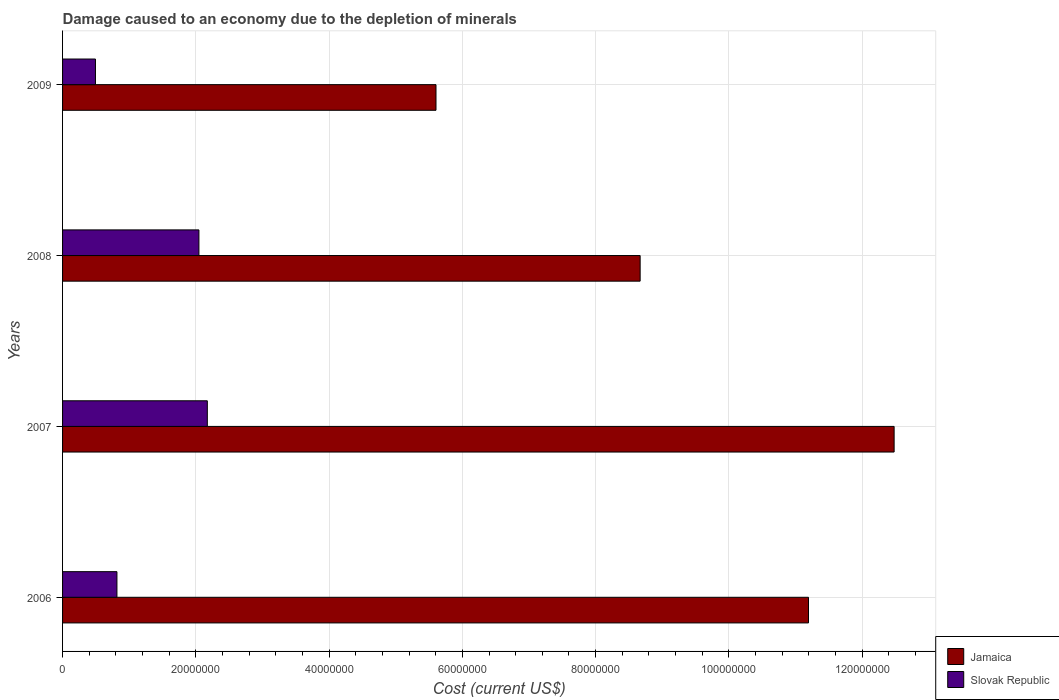How many different coloured bars are there?
Your response must be concise. 2. How many bars are there on the 2nd tick from the top?
Offer a very short reply. 2. What is the label of the 4th group of bars from the top?
Offer a very short reply. 2006. In how many cases, is the number of bars for a given year not equal to the number of legend labels?
Ensure brevity in your answer.  0. What is the cost of damage caused due to the depletion of minerals in Jamaica in 2007?
Give a very brief answer. 1.25e+08. Across all years, what is the maximum cost of damage caused due to the depletion of minerals in Slovak Republic?
Offer a very short reply. 2.17e+07. Across all years, what is the minimum cost of damage caused due to the depletion of minerals in Jamaica?
Ensure brevity in your answer.  5.60e+07. In which year was the cost of damage caused due to the depletion of minerals in Jamaica maximum?
Offer a very short reply. 2007. What is the total cost of damage caused due to the depletion of minerals in Jamaica in the graph?
Provide a short and direct response. 3.79e+08. What is the difference between the cost of damage caused due to the depletion of minerals in Slovak Republic in 2006 and that in 2007?
Your answer should be very brief. -1.36e+07. What is the difference between the cost of damage caused due to the depletion of minerals in Jamaica in 2008 and the cost of damage caused due to the depletion of minerals in Slovak Republic in 2007?
Keep it short and to the point. 6.50e+07. What is the average cost of damage caused due to the depletion of minerals in Slovak Republic per year?
Provide a succinct answer. 1.38e+07. In the year 2008, what is the difference between the cost of damage caused due to the depletion of minerals in Jamaica and cost of damage caused due to the depletion of minerals in Slovak Republic?
Your answer should be very brief. 6.62e+07. In how many years, is the cost of damage caused due to the depletion of minerals in Slovak Republic greater than 4000000 US$?
Provide a short and direct response. 4. What is the ratio of the cost of damage caused due to the depletion of minerals in Slovak Republic in 2007 to that in 2008?
Your answer should be compact. 1.06. Is the cost of damage caused due to the depletion of minerals in Slovak Republic in 2006 less than that in 2007?
Provide a short and direct response. Yes. Is the difference between the cost of damage caused due to the depletion of minerals in Jamaica in 2007 and 2008 greater than the difference between the cost of damage caused due to the depletion of minerals in Slovak Republic in 2007 and 2008?
Make the answer very short. Yes. What is the difference between the highest and the second highest cost of damage caused due to the depletion of minerals in Jamaica?
Your answer should be very brief. 1.29e+07. What is the difference between the highest and the lowest cost of damage caused due to the depletion of minerals in Slovak Republic?
Offer a very short reply. 1.68e+07. What does the 2nd bar from the top in 2009 represents?
Make the answer very short. Jamaica. What does the 2nd bar from the bottom in 2009 represents?
Provide a succinct answer. Slovak Republic. How many bars are there?
Provide a short and direct response. 8. Are all the bars in the graph horizontal?
Provide a succinct answer. Yes. What is the difference between two consecutive major ticks on the X-axis?
Give a very brief answer. 2.00e+07. Are the values on the major ticks of X-axis written in scientific E-notation?
Provide a short and direct response. No. How are the legend labels stacked?
Provide a short and direct response. Vertical. What is the title of the graph?
Your response must be concise. Damage caused to an economy due to the depletion of minerals. Does "Belgium" appear as one of the legend labels in the graph?
Your answer should be compact. No. What is the label or title of the X-axis?
Your response must be concise. Cost (current US$). What is the label or title of the Y-axis?
Your answer should be compact. Years. What is the Cost (current US$) of Jamaica in 2006?
Ensure brevity in your answer.  1.12e+08. What is the Cost (current US$) in Slovak Republic in 2006?
Give a very brief answer. 8.16e+06. What is the Cost (current US$) of Jamaica in 2007?
Make the answer very short. 1.25e+08. What is the Cost (current US$) of Slovak Republic in 2007?
Keep it short and to the point. 2.17e+07. What is the Cost (current US$) of Jamaica in 2008?
Ensure brevity in your answer.  8.67e+07. What is the Cost (current US$) of Slovak Republic in 2008?
Offer a terse response. 2.05e+07. What is the Cost (current US$) of Jamaica in 2009?
Offer a terse response. 5.60e+07. What is the Cost (current US$) of Slovak Republic in 2009?
Make the answer very short. 4.94e+06. Across all years, what is the maximum Cost (current US$) of Jamaica?
Offer a terse response. 1.25e+08. Across all years, what is the maximum Cost (current US$) in Slovak Republic?
Offer a terse response. 2.17e+07. Across all years, what is the minimum Cost (current US$) in Jamaica?
Your answer should be compact. 5.60e+07. Across all years, what is the minimum Cost (current US$) in Slovak Republic?
Your response must be concise. 4.94e+06. What is the total Cost (current US$) in Jamaica in the graph?
Provide a short and direct response. 3.79e+08. What is the total Cost (current US$) in Slovak Republic in the graph?
Keep it short and to the point. 5.53e+07. What is the difference between the Cost (current US$) in Jamaica in 2006 and that in 2007?
Your answer should be very brief. -1.29e+07. What is the difference between the Cost (current US$) of Slovak Republic in 2006 and that in 2007?
Make the answer very short. -1.36e+07. What is the difference between the Cost (current US$) of Jamaica in 2006 and that in 2008?
Provide a succinct answer. 2.53e+07. What is the difference between the Cost (current US$) in Slovak Republic in 2006 and that in 2008?
Give a very brief answer. -1.23e+07. What is the difference between the Cost (current US$) in Jamaica in 2006 and that in 2009?
Offer a very short reply. 5.59e+07. What is the difference between the Cost (current US$) of Slovak Republic in 2006 and that in 2009?
Keep it short and to the point. 3.22e+06. What is the difference between the Cost (current US$) of Jamaica in 2007 and that in 2008?
Offer a terse response. 3.81e+07. What is the difference between the Cost (current US$) of Slovak Republic in 2007 and that in 2008?
Make the answer very short. 1.26e+06. What is the difference between the Cost (current US$) of Jamaica in 2007 and that in 2009?
Keep it short and to the point. 6.88e+07. What is the difference between the Cost (current US$) in Slovak Republic in 2007 and that in 2009?
Offer a very short reply. 1.68e+07. What is the difference between the Cost (current US$) of Jamaica in 2008 and that in 2009?
Ensure brevity in your answer.  3.06e+07. What is the difference between the Cost (current US$) of Slovak Republic in 2008 and that in 2009?
Give a very brief answer. 1.55e+07. What is the difference between the Cost (current US$) of Jamaica in 2006 and the Cost (current US$) of Slovak Republic in 2007?
Ensure brevity in your answer.  9.02e+07. What is the difference between the Cost (current US$) in Jamaica in 2006 and the Cost (current US$) in Slovak Republic in 2008?
Offer a terse response. 9.15e+07. What is the difference between the Cost (current US$) of Jamaica in 2006 and the Cost (current US$) of Slovak Republic in 2009?
Give a very brief answer. 1.07e+08. What is the difference between the Cost (current US$) in Jamaica in 2007 and the Cost (current US$) in Slovak Republic in 2008?
Make the answer very short. 1.04e+08. What is the difference between the Cost (current US$) in Jamaica in 2007 and the Cost (current US$) in Slovak Republic in 2009?
Keep it short and to the point. 1.20e+08. What is the difference between the Cost (current US$) in Jamaica in 2008 and the Cost (current US$) in Slovak Republic in 2009?
Give a very brief answer. 8.17e+07. What is the average Cost (current US$) of Jamaica per year?
Your answer should be very brief. 9.49e+07. What is the average Cost (current US$) of Slovak Republic per year?
Your response must be concise. 1.38e+07. In the year 2006, what is the difference between the Cost (current US$) in Jamaica and Cost (current US$) in Slovak Republic?
Provide a short and direct response. 1.04e+08. In the year 2007, what is the difference between the Cost (current US$) in Jamaica and Cost (current US$) in Slovak Republic?
Provide a short and direct response. 1.03e+08. In the year 2008, what is the difference between the Cost (current US$) in Jamaica and Cost (current US$) in Slovak Republic?
Offer a very short reply. 6.62e+07. In the year 2009, what is the difference between the Cost (current US$) in Jamaica and Cost (current US$) in Slovak Republic?
Offer a very short reply. 5.11e+07. What is the ratio of the Cost (current US$) of Jamaica in 2006 to that in 2007?
Give a very brief answer. 0.9. What is the ratio of the Cost (current US$) of Slovak Republic in 2006 to that in 2007?
Offer a very short reply. 0.38. What is the ratio of the Cost (current US$) in Jamaica in 2006 to that in 2008?
Give a very brief answer. 1.29. What is the ratio of the Cost (current US$) in Slovak Republic in 2006 to that in 2008?
Provide a succinct answer. 0.4. What is the ratio of the Cost (current US$) in Jamaica in 2006 to that in 2009?
Make the answer very short. 2. What is the ratio of the Cost (current US$) in Slovak Republic in 2006 to that in 2009?
Offer a very short reply. 1.65. What is the ratio of the Cost (current US$) in Jamaica in 2007 to that in 2008?
Give a very brief answer. 1.44. What is the ratio of the Cost (current US$) in Slovak Republic in 2007 to that in 2008?
Keep it short and to the point. 1.06. What is the ratio of the Cost (current US$) of Jamaica in 2007 to that in 2009?
Give a very brief answer. 2.23. What is the ratio of the Cost (current US$) of Jamaica in 2008 to that in 2009?
Offer a terse response. 1.55. What is the ratio of the Cost (current US$) of Slovak Republic in 2008 to that in 2009?
Give a very brief answer. 4.14. What is the difference between the highest and the second highest Cost (current US$) of Jamaica?
Your answer should be very brief. 1.29e+07. What is the difference between the highest and the second highest Cost (current US$) of Slovak Republic?
Ensure brevity in your answer.  1.26e+06. What is the difference between the highest and the lowest Cost (current US$) in Jamaica?
Offer a terse response. 6.88e+07. What is the difference between the highest and the lowest Cost (current US$) of Slovak Republic?
Ensure brevity in your answer.  1.68e+07. 